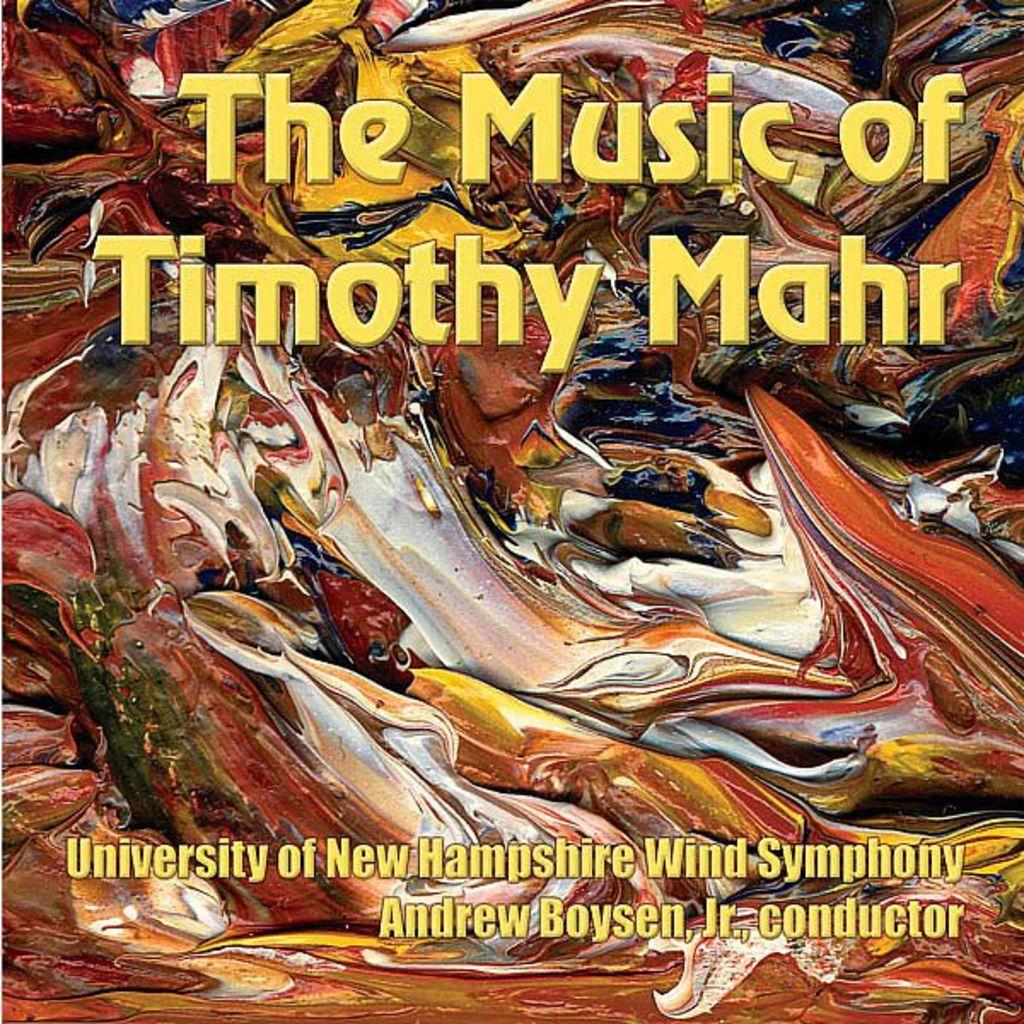Provide a one-sentence caption for the provided image. a piece of artwork with The Music of Timothy Mahr University of New Hampshire Wind Symphony Andrew Boysen, J., conductor. 